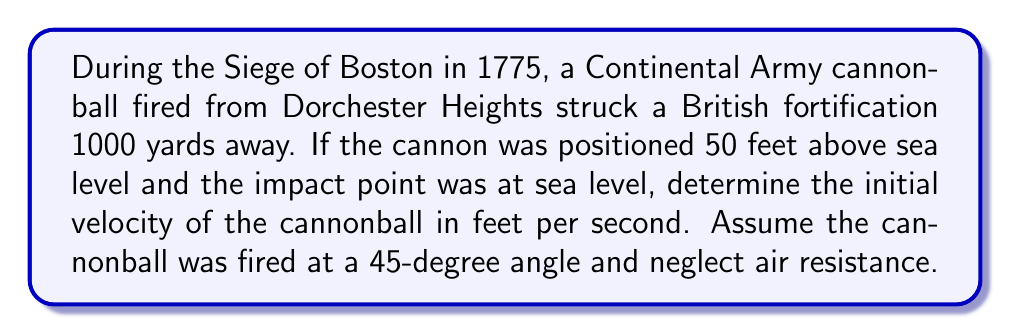Can you solve this math problem? To solve this problem, we'll use the equations of motion for projectile motion. Let's break it down step-by-step:

1. Given information:
   - Horizontal distance (x) = 1000 yards = 3000 feet
   - Initial height (h₀) = 50 feet
   - Final height (h) = 0 feet (sea level)
   - Angle of projection (θ) = 45°
   - Acceleration due to gravity (g) = 32.2 ft/s²

2. We'll use the following equations:
   $$x = v_0 \cos(\theta) \cdot t$$
   $$y = h_0 + v_0 \sin(\theta) \cdot t - \frac{1}{2}gt^2$$

3. At the point of impact, y = 0. Substituting this into the second equation:
   $$0 = 50 + v_0 \sin(45°) \cdot t - \frac{1}{2}(32.2)t^2$$

4. Simplify using sin(45°) = cos(45°) = $\frac{1}{\sqrt{2}}$:
   $$0 = 50 + \frac{v_0}{\sqrt{2}} \cdot t - 16.1t^2$$

5. From the first equation, we can express t in terms of v₀:
   $$t = \frac{3000}{v_0 \cos(45°)} = \frac{3000\sqrt{2}}{v_0}$$

6. Substitute this into the equation from step 4:
   $$0 = 50 + \frac{v_0}{\sqrt{2}} \cdot \frac{3000\sqrt{2}}{v_0} - 16.1(\frac{3000\sqrt{2}}{v_0})^2$$

7. Simplify:
   $$0 = 50 + 3000 - \frac{289,800,000}{v_0^2}$$

8. Solve for v₀:
   $$\frac{289,800,000}{v_0^2} = 3050$$
   $$v_0^2 = \frac{289,800,000}{3050} = 95,016.39$$
   $$v_0 = \sqrt{95,016.39} \approx 308.25 \text{ ft/s}$$
Answer: 308.25 ft/s 